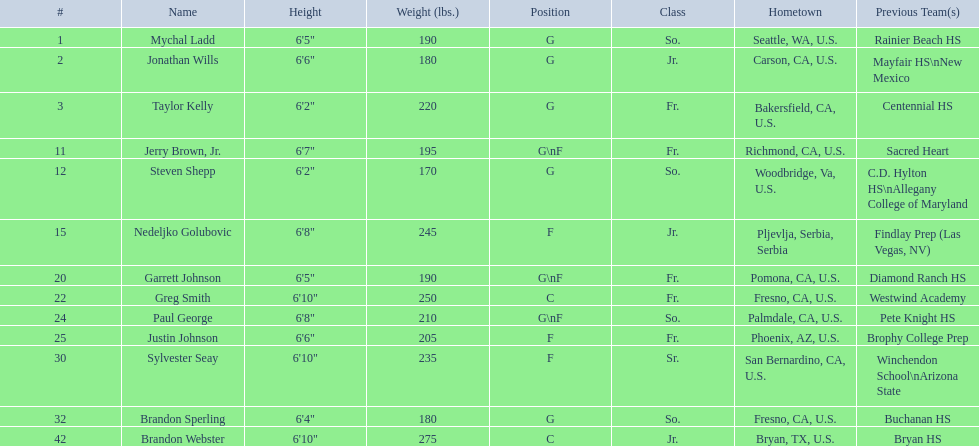What are the listed classes of the players? So., Jr., Fr., Fr., So., Jr., Fr., Fr., So., Fr., Sr., So., Jr. Which of these is not from the us? Jr. To which name does that entry correspond to? Nedeljko Golubovic. 